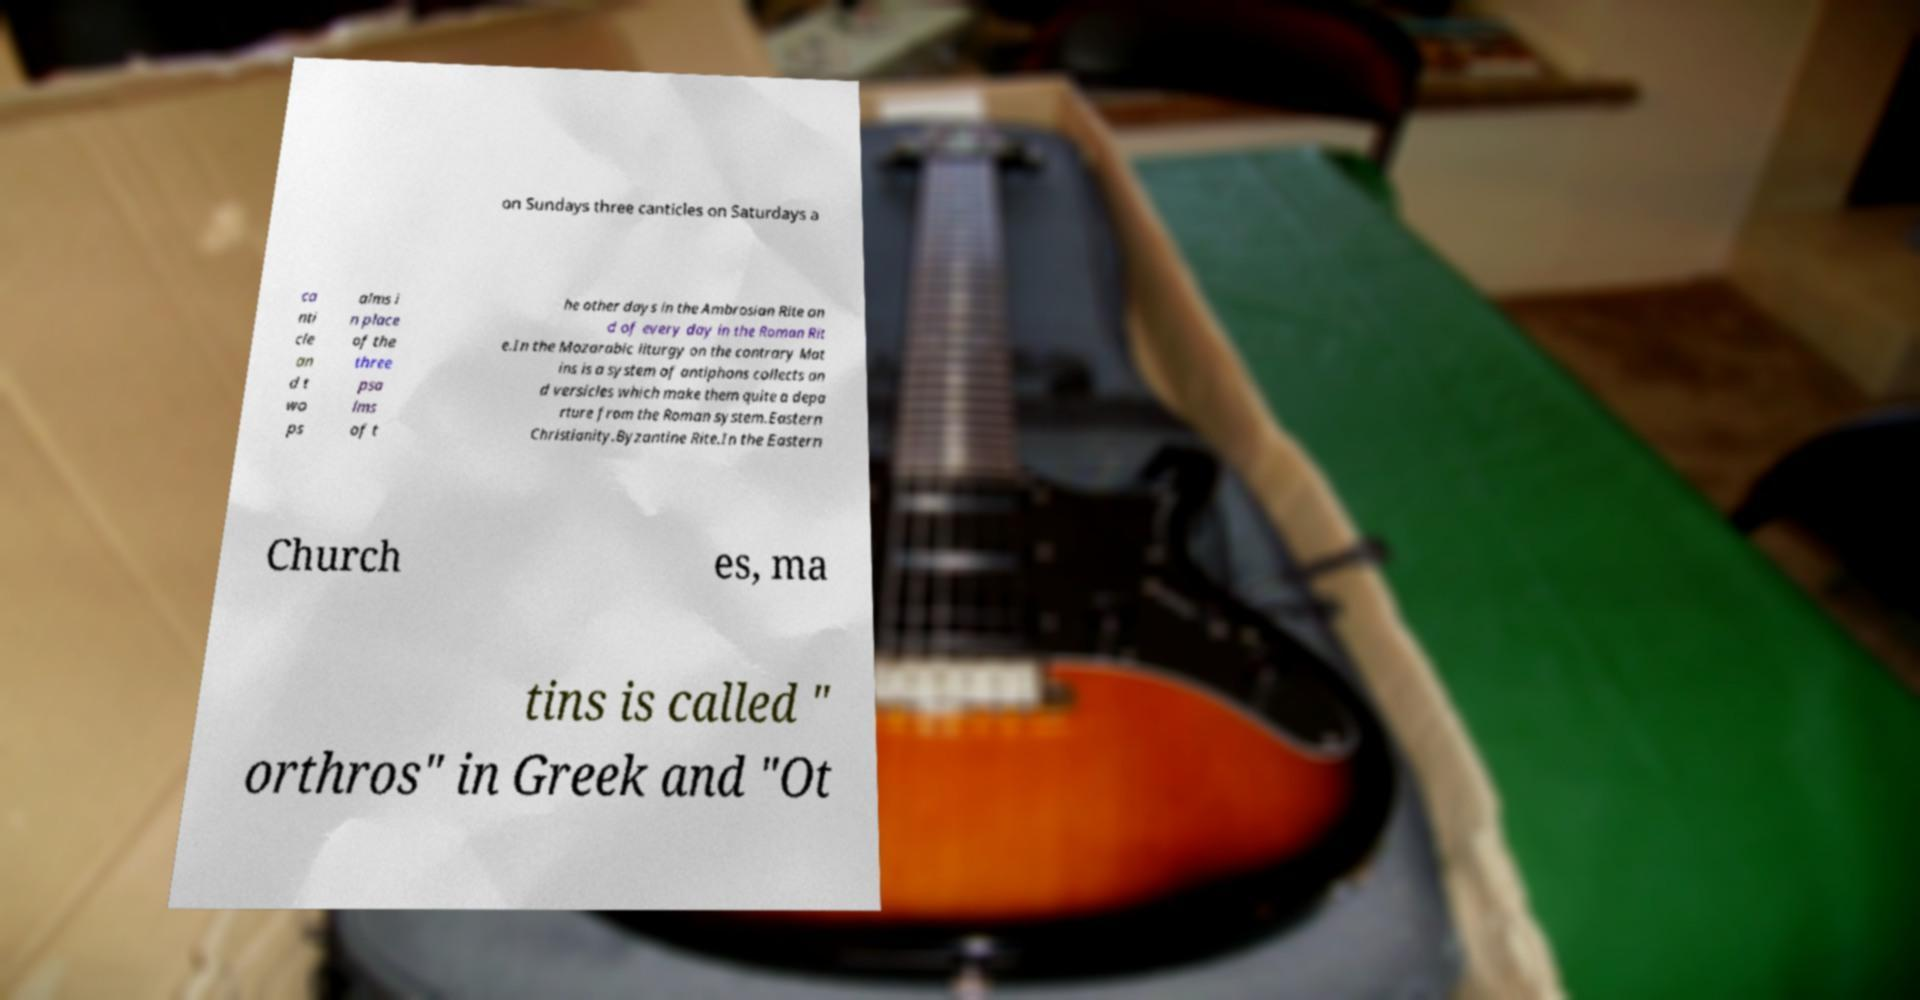There's text embedded in this image that I need extracted. Can you transcribe it verbatim? on Sundays three canticles on Saturdays a ca nti cle an d t wo ps alms i n place of the three psa lms of t he other days in the Ambrosian Rite an d of every day in the Roman Rit e.In the Mozarabic liturgy on the contrary Mat ins is a system of antiphons collects an d versicles which make them quite a depa rture from the Roman system.Eastern Christianity.Byzantine Rite.In the Eastern Church es, ma tins is called " orthros" in Greek and "Ot 